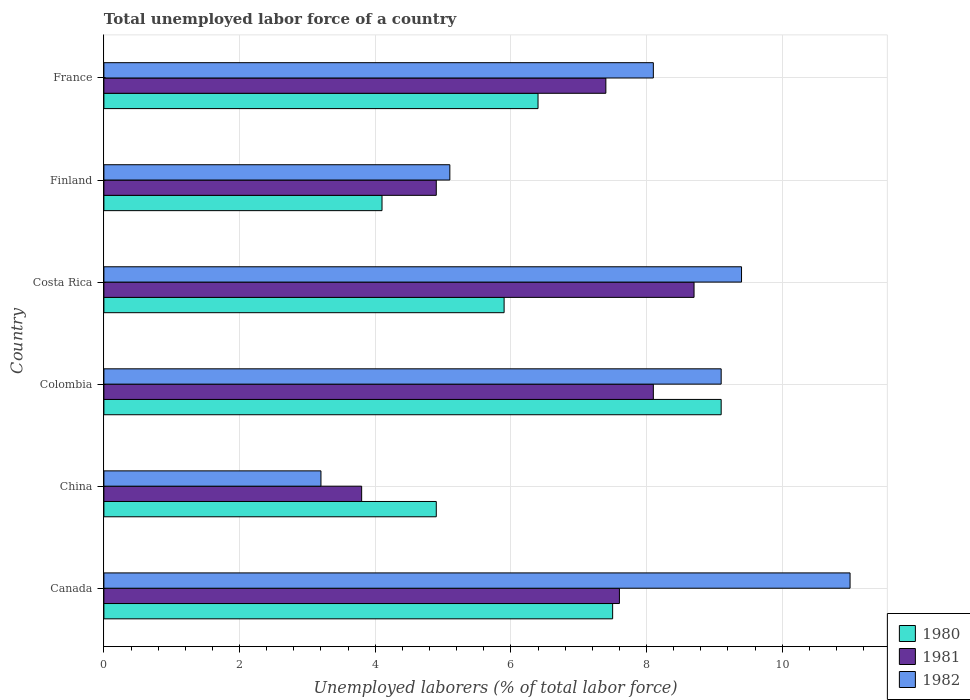How many different coloured bars are there?
Ensure brevity in your answer.  3. Are the number of bars per tick equal to the number of legend labels?
Give a very brief answer. Yes. Are the number of bars on each tick of the Y-axis equal?
Offer a very short reply. Yes. How many bars are there on the 3rd tick from the top?
Make the answer very short. 3. What is the label of the 1st group of bars from the top?
Ensure brevity in your answer.  France. In how many cases, is the number of bars for a given country not equal to the number of legend labels?
Keep it short and to the point. 0. What is the total unemployed labor force in 1982 in France?
Offer a very short reply. 8.1. Across all countries, what is the maximum total unemployed labor force in 1981?
Keep it short and to the point. 8.7. Across all countries, what is the minimum total unemployed labor force in 1980?
Offer a terse response. 4.1. What is the total total unemployed labor force in 1982 in the graph?
Offer a terse response. 45.9. What is the difference between the total unemployed labor force in 1980 in Canada and that in France?
Give a very brief answer. 1.1. What is the difference between the total unemployed labor force in 1980 in Canada and the total unemployed labor force in 1982 in Colombia?
Provide a succinct answer. -1.6. What is the average total unemployed labor force in 1981 per country?
Keep it short and to the point. 6.75. What is the difference between the total unemployed labor force in 1981 and total unemployed labor force in 1982 in Canada?
Offer a very short reply. -3.4. In how many countries, is the total unemployed labor force in 1982 greater than 6 %?
Your answer should be compact. 4. What is the ratio of the total unemployed labor force in 1980 in Colombia to that in Costa Rica?
Offer a very short reply. 1.54. What is the difference between the highest and the second highest total unemployed labor force in 1981?
Give a very brief answer. 0.6. What is the difference between the highest and the lowest total unemployed labor force in 1981?
Ensure brevity in your answer.  4.9. Is the sum of the total unemployed labor force in 1980 in China and Colombia greater than the maximum total unemployed labor force in 1981 across all countries?
Keep it short and to the point. Yes. What does the 1st bar from the bottom in Finland represents?
Your response must be concise. 1980. Is it the case that in every country, the sum of the total unemployed labor force in 1981 and total unemployed labor force in 1982 is greater than the total unemployed labor force in 1980?
Provide a short and direct response. Yes. How many countries are there in the graph?
Offer a terse response. 6. What is the difference between two consecutive major ticks on the X-axis?
Your response must be concise. 2. Where does the legend appear in the graph?
Offer a very short reply. Bottom right. How many legend labels are there?
Your answer should be very brief. 3. How are the legend labels stacked?
Your response must be concise. Vertical. What is the title of the graph?
Offer a terse response. Total unemployed labor force of a country. What is the label or title of the X-axis?
Offer a terse response. Unemployed laborers (% of total labor force). What is the label or title of the Y-axis?
Provide a short and direct response. Country. What is the Unemployed laborers (% of total labor force) of 1981 in Canada?
Provide a short and direct response. 7.6. What is the Unemployed laborers (% of total labor force) in 1982 in Canada?
Your answer should be very brief. 11. What is the Unemployed laborers (% of total labor force) of 1980 in China?
Offer a terse response. 4.9. What is the Unemployed laborers (% of total labor force) in 1981 in China?
Provide a succinct answer. 3.8. What is the Unemployed laborers (% of total labor force) in 1982 in China?
Keep it short and to the point. 3.2. What is the Unemployed laborers (% of total labor force) in 1980 in Colombia?
Your answer should be very brief. 9.1. What is the Unemployed laborers (% of total labor force) of 1981 in Colombia?
Give a very brief answer. 8.1. What is the Unemployed laborers (% of total labor force) of 1982 in Colombia?
Give a very brief answer. 9.1. What is the Unemployed laborers (% of total labor force) of 1980 in Costa Rica?
Your answer should be compact. 5.9. What is the Unemployed laborers (% of total labor force) of 1981 in Costa Rica?
Give a very brief answer. 8.7. What is the Unemployed laborers (% of total labor force) in 1982 in Costa Rica?
Provide a succinct answer. 9.4. What is the Unemployed laborers (% of total labor force) of 1980 in Finland?
Your response must be concise. 4.1. What is the Unemployed laborers (% of total labor force) in 1981 in Finland?
Offer a terse response. 4.9. What is the Unemployed laborers (% of total labor force) of 1982 in Finland?
Provide a succinct answer. 5.1. What is the Unemployed laborers (% of total labor force) in 1980 in France?
Give a very brief answer. 6.4. What is the Unemployed laborers (% of total labor force) in 1981 in France?
Offer a terse response. 7.4. What is the Unemployed laborers (% of total labor force) in 1982 in France?
Offer a terse response. 8.1. Across all countries, what is the maximum Unemployed laborers (% of total labor force) of 1980?
Give a very brief answer. 9.1. Across all countries, what is the maximum Unemployed laborers (% of total labor force) of 1981?
Ensure brevity in your answer.  8.7. Across all countries, what is the maximum Unemployed laborers (% of total labor force) in 1982?
Give a very brief answer. 11. Across all countries, what is the minimum Unemployed laborers (% of total labor force) of 1980?
Keep it short and to the point. 4.1. Across all countries, what is the minimum Unemployed laborers (% of total labor force) in 1981?
Your answer should be compact. 3.8. Across all countries, what is the minimum Unemployed laborers (% of total labor force) of 1982?
Make the answer very short. 3.2. What is the total Unemployed laborers (% of total labor force) in 1980 in the graph?
Make the answer very short. 37.9. What is the total Unemployed laborers (% of total labor force) in 1981 in the graph?
Keep it short and to the point. 40.5. What is the total Unemployed laborers (% of total labor force) of 1982 in the graph?
Your answer should be very brief. 45.9. What is the difference between the Unemployed laborers (% of total labor force) in 1980 in Canada and that in China?
Your answer should be compact. 2.6. What is the difference between the Unemployed laborers (% of total labor force) of 1981 in Canada and that in China?
Give a very brief answer. 3.8. What is the difference between the Unemployed laborers (% of total labor force) in 1982 in Canada and that in China?
Keep it short and to the point. 7.8. What is the difference between the Unemployed laborers (% of total labor force) in 1980 in Canada and that in Colombia?
Your answer should be very brief. -1.6. What is the difference between the Unemployed laborers (% of total labor force) in 1982 in Canada and that in Costa Rica?
Your answer should be compact. 1.6. What is the difference between the Unemployed laborers (% of total labor force) of 1982 in Canada and that in Finland?
Provide a succinct answer. 5.9. What is the difference between the Unemployed laborers (% of total labor force) in 1980 in Canada and that in France?
Keep it short and to the point. 1.1. What is the difference between the Unemployed laborers (% of total labor force) in 1981 in China and that in Costa Rica?
Your answer should be very brief. -4.9. What is the difference between the Unemployed laborers (% of total labor force) of 1982 in China and that in Costa Rica?
Make the answer very short. -6.2. What is the difference between the Unemployed laborers (% of total labor force) in 1981 in China and that in Finland?
Provide a succinct answer. -1.1. What is the difference between the Unemployed laborers (% of total labor force) of 1980 in Colombia and that in Costa Rica?
Offer a very short reply. 3.2. What is the difference between the Unemployed laborers (% of total labor force) in 1981 in Colombia and that in Costa Rica?
Offer a very short reply. -0.6. What is the difference between the Unemployed laborers (% of total labor force) of 1982 in Colombia and that in Costa Rica?
Provide a short and direct response. -0.3. What is the difference between the Unemployed laborers (% of total labor force) in 1982 in Colombia and that in Finland?
Provide a short and direct response. 4. What is the difference between the Unemployed laborers (% of total labor force) of 1980 in Colombia and that in France?
Your response must be concise. 2.7. What is the difference between the Unemployed laborers (% of total labor force) of 1981 in Costa Rica and that in Finland?
Provide a short and direct response. 3.8. What is the difference between the Unemployed laborers (% of total labor force) in 1982 in Costa Rica and that in Finland?
Offer a terse response. 4.3. What is the difference between the Unemployed laborers (% of total labor force) in 1981 in Costa Rica and that in France?
Offer a terse response. 1.3. What is the difference between the Unemployed laborers (% of total labor force) of 1981 in Finland and that in France?
Provide a succinct answer. -2.5. What is the difference between the Unemployed laborers (% of total labor force) of 1980 in Canada and the Unemployed laborers (% of total labor force) of 1981 in China?
Your response must be concise. 3.7. What is the difference between the Unemployed laborers (% of total labor force) in 1980 in Canada and the Unemployed laborers (% of total labor force) in 1982 in China?
Offer a very short reply. 4.3. What is the difference between the Unemployed laborers (% of total labor force) of 1981 in Canada and the Unemployed laborers (% of total labor force) of 1982 in China?
Your response must be concise. 4.4. What is the difference between the Unemployed laborers (% of total labor force) in 1980 in Canada and the Unemployed laborers (% of total labor force) in 1981 in Colombia?
Ensure brevity in your answer.  -0.6. What is the difference between the Unemployed laborers (% of total labor force) of 1981 in Canada and the Unemployed laborers (% of total labor force) of 1982 in Costa Rica?
Offer a terse response. -1.8. What is the difference between the Unemployed laborers (% of total labor force) of 1980 in Canada and the Unemployed laborers (% of total labor force) of 1981 in Finland?
Offer a very short reply. 2.6. What is the difference between the Unemployed laborers (% of total labor force) in 1981 in Canada and the Unemployed laborers (% of total labor force) in 1982 in Finland?
Ensure brevity in your answer.  2.5. What is the difference between the Unemployed laborers (% of total labor force) of 1980 in Canada and the Unemployed laborers (% of total labor force) of 1981 in France?
Keep it short and to the point. 0.1. What is the difference between the Unemployed laborers (% of total labor force) of 1980 in Canada and the Unemployed laborers (% of total labor force) of 1982 in France?
Keep it short and to the point. -0.6. What is the difference between the Unemployed laborers (% of total labor force) in 1980 in China and the Unemployed laborers (% of total labor force) in 1981 in Colombia?
Your answer should be compact. -3.2. What is the difference between the Unemployed laborers (% of total labor force) in 1980 in China and the Unemployed laborers (% of total labor force) in 1982 in Colombia?
Your answer should be very brief. -4.2. What is the difference between the Unemployed laborers (% of total labor force) of 1980 in China and the Unemployed laborers (% of total labor force) of 1981 in Costa Rica?
Provide a short and direct response. -3.8. What is the difference between the Unemployed laborers (% of total labor force) of 1980 in China and the Unemployed laborers (% of total labor force) of 1981 in Finland?
Keep it short and to the point. 0. What is the difference between the Unemployed laborers (% of total labor force) of 1980 in China and the Unemployed laborers (% of total labor force) of 1981 in France?
Ensure brevity in your answer.  -2.5. What is the difference between the Unemployed laborers (% of total labor force) of 1980 in China and the Unemployed laborers (% of total labor force) of 1982 in France?
Your answer should be compact. -3.2. What is the difference between the Unemployed laborers (% of total labor force) in 1980 in Colombia and the Unemployed laborers (% of total labor force) in 1981 in Costa Rica?
Offer a very short reply. 0.4. What is the difference between the Unemployed laborers (% of total labor force) of 1981 in Colombia and the Unemployed laborers (% of total labor force) of 1982 in Costa Rica?
Keep it short and to the point. -1.3. What is the difference between the Unemployed laborers (% of total labor force) of 1980 in Colombia and the Unemployed laborers (% of total labor force) of 1981 in Finland?
Your response must be concise. 4.2. What is the difference between the Unemployed laborers (% of total labor force) of 1980 in Colombia and the Unemployed laborers (% of total labor force) of 1982 in Finland?
Provide a succinct answer. 4. What is the difference between the Unemployed laborers (% of total labor force) of 1981 in Colombia and the Unemployed laborers (% of total labor force) of 1982 in France?
Offer a terse response. 0. What is the difference between the Unemployed laborers (% of total labor force) of 1980 in Costa Rica and the Unemployed laborers (% of total labor force) of 1981 in Finland?
Make the answer very short. 1. What is the difference between the Unemployed laborers (% of total labor force) of 1980 in Costa Rica and the Unemployed laborers (% of total labor force) of 1982 in Finland?
Make the answer very short. 0.8. What is the difference between the Unemployed laborers (% of total labor force) of 1981 in Costa Rica and the Unemployed laborers (% of total labor force) of 1982 in Finland?
Your answer should be compact. 3.6. What is the difference between the Unemployed laborers (% of total labor force) in 1980 in Costa Rica and the Unemployed laborers (% of total labor force) in 1981 in France?
Make the answer very short. -1.5. What is the difference between the Unemployed laborers (% of total labor force) in 1980 in Finland and the Unemployed laborers (% of total labor force) in 1981 in France?
Provide a succinct answer. -3.3. What is the difference between the Unemployed laborers (% of total labor force) of 1980 in Finland and the Unemployed laborers (% of total labor force) of 1982 in France?
Give a very brief answer. -4. What is the average Unemployed laborers (% of total labor force) in 1980 per country?
Your answer should be compact. 6.32. What is the average Unemployed laborers (% of total labor force) of 1981 per country?
Provide a short and direct response. 6.75. What is the average Unemployed laborers (% of total labor force) of 1982 per country?
Provide a short and direct response. 7.65. What is the difference between the Unemployed laborers (% of total labor force) in 1980 and Unemployed laborers (% of total labor force) in 1981 in Canada?
Provide a short and direct response. -0.1. What is the difference between the Unemployed laborers (% of total labor force) in 1980 and Unemployed laborers (% of total labor force) in 1982 in Canada?
Your answer should be compact. -3.5. What is the difference between the Unemployed laborers (% of total labor force) in 1980 and Unemployed laborers (% of total labor force) in 1982 in Colombia?
Your response must be concise. 0. What is the difference between the Unemployed laborers (% of total labor force) in 1980 and Unemployed laborers (% of total labor force) in 1981 in Costa Rica?
Provide a short and direct response. -2.8. What is the difference between the Unemployed laborers (% of total labor force) in 1980 and Unemployed laborers (% of total labor force) in 1982 in Costa Rica?
Your answer should be very brief. -3.5. What is the difference between the Unemployed laborers (% of total labor force) of 1981 and Unemployed laborers (% of total labor force) of 1982 in Costa Rica?
Keep it short and to the point. -0.7. What is the difference between the Unemployed laborers (% of total labor force) of 1980 and Unemployed laborers (% of total labor force) of 1982 in Finland?
Offer a terse response. -1. What is the difference between the Unemployed laborers (% of total labor force) of 1981 and Unemployed laborers (% of total labor force) of 1982 in Finland?
Provide a short and direct response. -0.2. What is the difference between the Unemployed laborers (% of total labor force) of 1981 and Unemployed laborers (% of total labor force) of 1982 in France?
Give a very brief answer. -0.7. What is the ratio of the Unemployed laborers (% of total labor force) in 1980 in Canada to that in China?
Your response must be concise. 1.53. What is the ratio of the Unemployed laborers (% of total labor force) of 1982 in Canada to that in China?
Offer a very short reply. 3.44. What is the ratio of the Unemployed laborers (% of total labor force) in 1980 in Canada to that in Colombia?
Provide a short and direct response. 0.82. What is the ratio of the Unemployed laborers (% of total labor force) in 1981 in Canada to that in Colombia?
Your response must be concise. 0.94. What is the ratio of the Unemployed laborers (% of total labor force) in 1982 in Canada to that in Colombia?
Offer a terse response. 1.21. What is the ratio of the Unemployed laborers (% of total labor force) in 1980 in Canada to that in Costa Rica?
Provide a succinct answer. 1.27. What is the ratio of the Unemployed laborers (% of total labor force) of 1981 in Canada to that in Costa Rica?
Your answer should be very brief. 0.87. What is the ratio of the Unemployed laborers (% of total labor force) of 1982 in Canada to that in Costa Rica?
Your response must be concise. 1.17. What is the ratio of the Unemployed laborers (% of total labor force) in 1980 in Canada to that in Finland?
Ensure brevity in your answer.  1.83. What is the ratio of the Unemployed laborers (% of total labor force) of 1981 in Canada to that in Finland?
Keep it short and to the point. 1.55. What is the ratio of the Unemployed laborers (% of total labor force) of 1982 in Canada to that in Finland?
Offer a terse response. 2.16. What is the ratio of the Unemployed laborers (% of total labor force) of 1980 in Canada to that in France?
Provide a short and direct response. 1.17. What is the ratio of the Unemployed laborers (% of total labor force) of 1981 in Canada to that in France?
Your answer should be compact. 1.03. What is the ratio of the Unemployed laborers (% of total labor force) of 1982 in Canada to that in France?
Provide a succinct answer. 1.36. What is the ratio of the Unemployed laborers (% of total labor force) of 1980 in China to that in Colombia?
Offer a very short reply. 0.54. What is the ratio of the Unemployed laborers (% of total labor force) in 1981 in China to that in Colombia?
Keep it short and to the point. 0.47. What is the ratio of the Unemployed laborers (% of total labor force) in 1982 in China to that in Colombia?
Offer a terse response. 0.35. What is the ratio of the Unemployed laborers (% of total labor force) in 1980 in China to that in Costa Rica?
Provide a short and direct response. 0.83. What is the ratio of the Unemployed laborers (% of total labor force) in 1981 in China to that in Costa Rica?
Your response must be concise. 0.44. What is the ratio of the Unemployed laborers (% of total labor force) in 1982 in China to that in Costa Rica?
Offer a terse response. 0.34. What is the ratio of the Unemployed laborers (% of total labor force) in 1980 in China to that in Finland?
Ensure brevity in your answer.  1.2. What is the ratio of the Unemployed laborers (% of total labor force) of 1981 in China to that in Finland?
Your answer should be very brief. 0.78. What is the ratio of the Unemployed laborers (% of total labor force) in 1982 in China to that in Finland?
Make the answer very short. 0.63. What is the ratio of the Unemployed laborers (% of total labor force) of 1980 in China to that in France?
Your response must be concise. 0.77. What is the ratio of the Unemployed laborers (% of total labor force) in 1981 in China to that in France?
Provide a succinct answer. 0.51. What is the ratio of the Unemployed laborers (% of total labor force) of 1982 in China to that in France?
Give a very brief answer. 0.4. What is the ratio of the Unemployed laborers (% of total labor force) of 1980 in Colombia to that in Costa Rica?
Your answer should be compact. 1.54. What is the ratio of the Unemployed laborers (% of total labor force) of 1981 in Colombia to that in Costa Rica?
Provide a succinct answer. 0.93. What is the ratio of the Unemployed laborers (% of total labor force) in 1982 in Colombia to that in Costa Rica?
Keep it short and to the point. 0.97. What is the ratio of the Unemployed laborers (% of total labor force) of 1980 in Colombia to that in Finland?
Provide a succinct answer. 2.22. What is the ratio of the Unemployed laborers (% of total labor force) in 1981 in Colombia to that in Finland?
Your response must be concise. 1.65. What is the ratio of the Unemployed laborers (% of total labor force) of 1982 in Colombia to that in Finland?
Your answer should be very brief. 1.78. What is the ratio of the Unemployed laborers (% of total labor force) of 1980 in Colombia to that in France?
Give a very brief answer. 1.42. What is the ratio of the Unemployed laborers (% of total labor force) of 1981 in Colombia to that in France?
Offer a terse response. 1.09. What is the ratio of the Unemployed laborers (% of total labor force) in 1982 in Colombia to that in France?
Ensure brevity in your answer.  1.12. What is the ratio of the Unemployed laborers (% of total labor force) of 1980 in Costa Rica to that in Finland?
Your answer should be compact. 1.44. What is the ratio of the Unemployed laborers (% of total labor force) of 1981 in Costa Rica to that in Finland?
Provide a succinct answer. 1.78. What is the ratio of the Unemployed laborers (% of total labor force) in 1982 in Costa Rica to that in Finland?
Make the answer very short. 1.84. What is the ratio of the Unemployed laborers (% of total labor force) in 1980 in Costa Rica to that in France?
Provide a succinct answer. 0.92. What is the ratio of the Unemployed laborers (% of total labor force) of 1981 in Costa Rica to that in France?
Provide a short and direct response. 1.18. What is the ratio of the Unemployed laborers (% of total labor force) in 1982 in Costa Rica to that in France?
Your answer should be compact. 1.16. What is the ratio of the Unemployed laborers (% of total labor force) in 1980 in Finland to that in France?
Your answer should be very brief. 0.64. What is the ratio of the Unemployed laborers (% of total labor force) in 1981 in Finland to that in France?
Keep it short and to the point. 0.66. What is the ratio of the Unemployed laborers (% of total labor force) in 1982 in Finland to that in France?
Offer a terse response. 0.63. What is the difference between the highest and the second highest Unemployed laborers (% of total labor force) in 1981?
Offer a very short reply. 0.6. What is the difference between the highest and the lowest Unemployed laborers (% of total labor force) of 1981?
Provide a short and direct response. 4.9. What is the difference between the highest and the lowest Unemployed laborers (% of total labor force) of 1982?
Give a very brief answer. 7.8. 